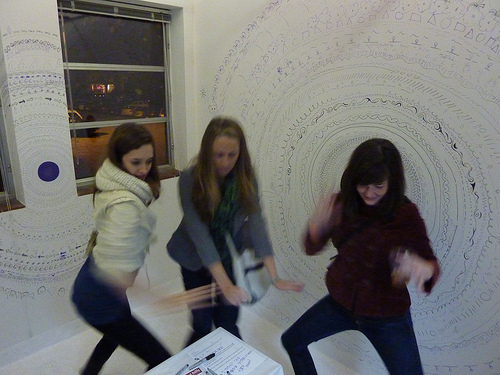<image>
Is the village behind the girls? Yes. From this viewpoint, the village is positioned behind the girls, with the girls partially or fully occluding the village. 